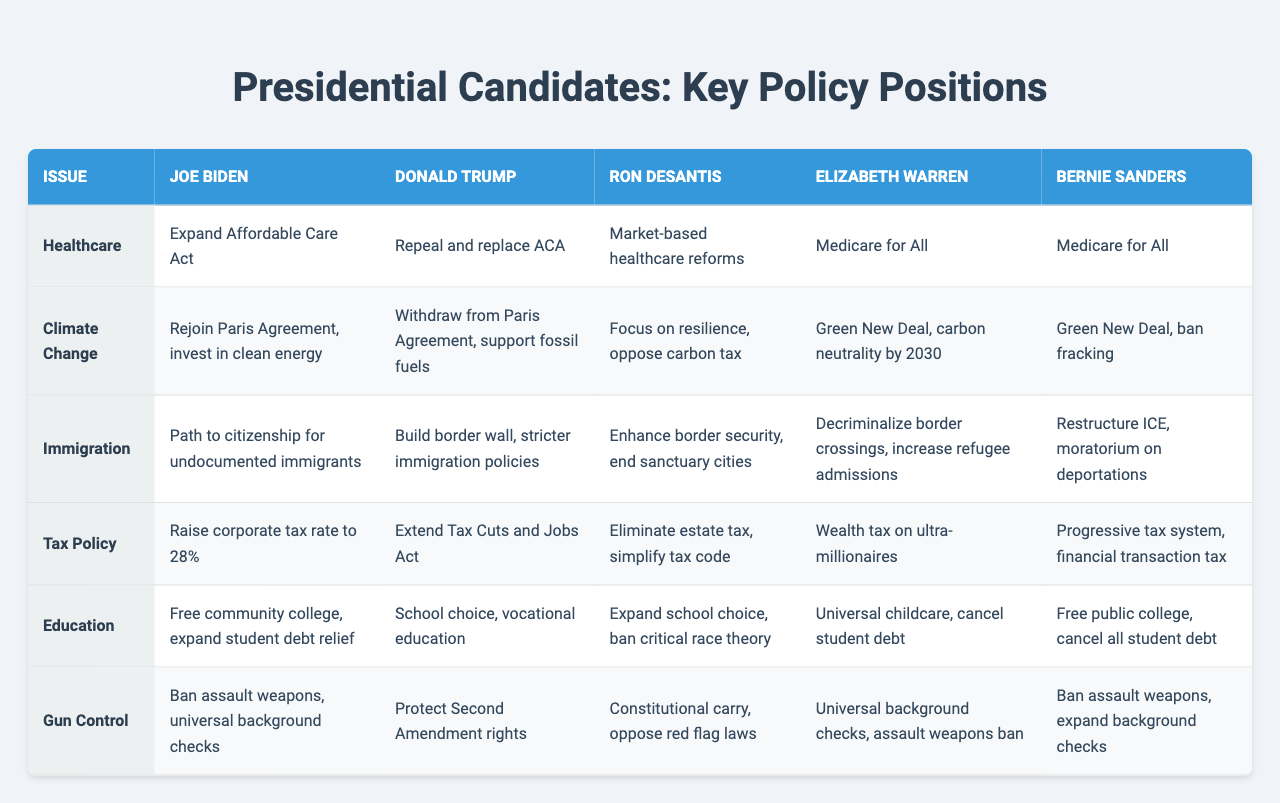What is Joe Biden's position on healthcare? According to the table, Joe Biden's healthcare position is to expand the Affordable Care Act.
Answer: Expand Affordable Care Act Which candidate supports "Medicare for All"? The table shows that both Elizabeth Warren and Bernie Sanders support "Medicare for All" as their healthcare policy positions.
Answer: Elizabeth Warren and Bernie Sanders What is the difference between Joe Biden's and Donald Trump's tax policies? Joe Biden aims to raise the corporate tax rate to 28%, while Donald Trump plans to extend the Tax Cuts and Jobs Act. The difference lies in Biden's intention to increase corporate taxes versus Trump's maintenance of lower rates from the previous legislation.
Answer: Raise corporate tax vs Extend Tax Cuts Which candidate has a stance against carbon taxes? According to the table, Ron DeSantis focuses on resilience and opposes carbon tax under his climate change policy.
Answer: Ron DeSantis Do any candidates propose a wealth tax? Yes, Elizabeth Warren proposes a wealth tax on ultra-millionaires as part of her tax policy.
Answer: Yes Who has the most comprehensive gun control measures listed in the table? Joe Biden and Elizabeth Warren both support measures like universal background checks and a ban on assault weapons, but Biden includes specific measures for background checks, indicating a potentially more comprehensive approach.
Answer: Joe Biden Which candidate supports school choice? Donald Trump and Ron DeSantis are both listed as supporting school choice in their education policies.
Answer: Donald Trump and Ron DeSantis If we consider the immigration policies, which candidates aim to enhance border security? Donald Trump aims to build a border wall and implement stricter immigration policies, whereas Ron DeSantis wants to enhance border security and end sanctuary cities. Both candidates focus on border security in their immigration policy.
Answer: Donald Trump and Ron DeSantis How do Biden's and Warren's views on education differ? Biden emphasizes free community college and expanding student debt relief, while Warren aims for universal childcare and cancelling student debt, indicating her focus is on wider accessibility and addressing debt more radically.
Answer: Differ in focus on debt relief vs childcare Which candidate shares a similar position on climate change policies? Both Elizabeth Warren and Bernie Sanders propose a Green New Deal as their climate change policy, showing their alignment on addressing climate issues.
Answer: Elizabeth Warren and Bernie Sanders 